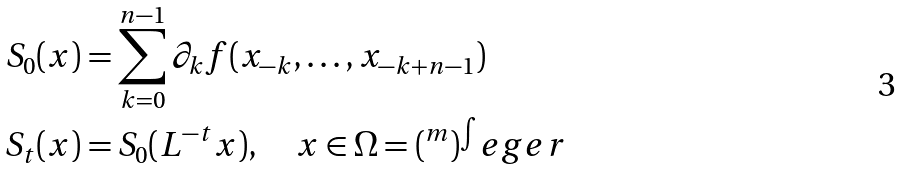<formula> <loc_0><loc_0><loc_500><loc_500>S _ { 0 } ( x ) & = \sum _ { k = 0 } ^ { n - 1 } \partial _ { k } f ( x _ { - k } , \dots , x _ { - k + n - 1 } ) \\ S _ { t } ( x ) & = S _ { 0 } ( L ^ { - t } x ) , \quad x \in \Omega = ( \real ^ { m } ) ^ { \int } e g e r</formula> 